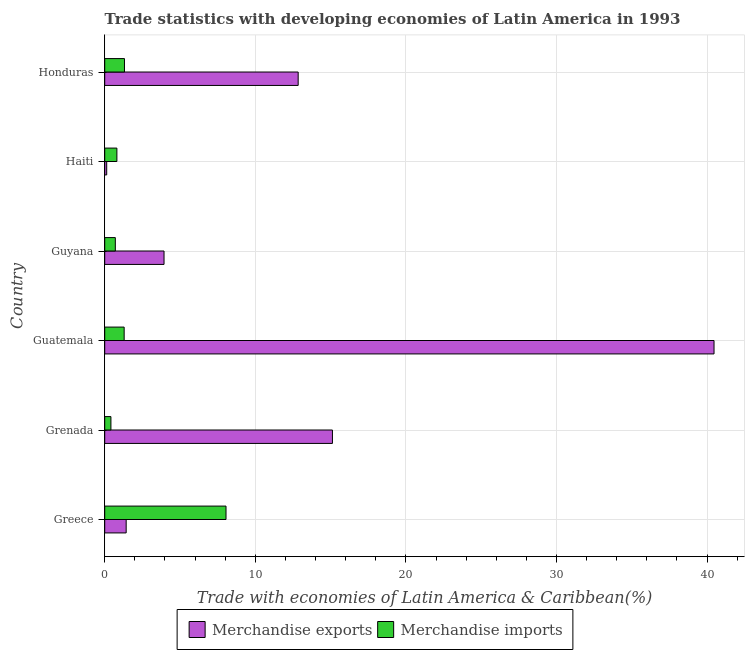How many different coloured bars are there?
Ensure brevity in your answer.  2. How many groups of bars are there?
Provide a short and direct response. 6. Are the number of bars per tick equal to the number of legend labels?
Make the answer very short. Yes. How many bars are there on the 2nd tick from the bottom?
Your response must be concise. 2. What is the label of the 3rd group of bars from the top?
Keep it short and to the point. Guyana. In how many cases, is the number of bars for a given country not equal to the number of legend labels?
Your answer should be compact. 0. What is the merchandise imports in Guatemala?
Your response must be concise. 1.29. Across all countries, what is the maximum merchandise exports?
Keep it short and to the point. 40.46. Across all countries, what is the minimum merchandise imports?
Make the answer very short. 0.41. In which country was the merchandise imports maximum?
Provide a short and direct response. Greece. In which country was the merchandise exports minimum?
Your answer should be compact. Haiti. What is the total merchandise exports in the graph?
Offer a terse response. 73.92. What is the difference between the merchandise imports in Guyana and that in Honduras?
Offer a very short reply. -0.61. What is the difference between the merchandise exports in Honduras and the merchandise imports in Haiti?
Offer a very short reply. 12.04. What is the average merchandise imports per country?
Offer a very short reply. 2.1. What is the difference between the merchandise imports and merchandise exports in Greece?
Your answer should be very brief. 6.63. In how many countries, is the merchandise imports greater than 2 %?
Your answer should be compact. 1. What is the ratio of the merchandise imports in Guyana to that in Honduras?
Keep it short and to the point. 0.54. Is the difference between the merchandise imports in Greece and Guyana greater than the difference between the merchandise exports in Greece and Guyana?
Offer a very short reply. Yes. What is the difference between the highest and the second highest merchandise imports?
Provide a short and direct response. 6.74. What is the difference between the highest and the lowest merchandise exports?
Offer a very short reply. 40.33. In how many countries, is the merchandise imports greater than the average merchandise imports taken over all countries?
Offer a very short reply. 1. Is the sum of the merchandise exports in Grenada and Guyana greater than the maximum merchandise imports across all countries?
Make the answer very short. Yes. What does the 1st bar from the top in Haiti represents?
Your response must be concise. Merchandise imports. How many bars are there?
Your response must be concise. 12. Are all the bars in the graph horizontal?
Offer a very short reply. Yes. How many countries are there in the graph?
Make the answer very short. 6. What is the difference between two consecutive major ticks on the X-axis?
Give a very brief answer. 10. Are the values on the major ticks of X-axis written in scientific E-notation?
Your response must be concise. No. What is the title of the graph?
Provide a short and direct response. Trade statistics with developing economies of Latin America in 1993. Does "Depositors" appear as one of the legend labels in the graph?
Offer a terse response. No. What is the label or title of the X-axis?
Provide a succinct answer. Trade with economies of Latin America & Caribbean(%). What is the Trade with economies of Latin America & Caribbean(%) of Merchandise exports in Greece?
Your answer should be very brief. 1.42. What is the Trade with economies of Latin America & Caribbean(%) of Merchandise imports in Greece?
Ensure brevity in your answer.  8.05. What is the Trade with economies of Latin America & Caribbean(%) in Merchandise exports in Grenada?
Your answer should be compact. 15.12. What is the Trade with economies of Latin America & Caribbean(%) of Merchandise imports in Grenada?
Provide a succinct answer. 0.41. What is the Trade with economies of Latin America & Caribbean(%) of Merchandise exports in Guatemala?
Offer a terse response. 40.46. What is the Trade with economies of Latin America & Caribbean(%) of Merchandise imports in Guatemala?
Offer a very short reply. 1.29. What is the Trade with economies of Latin America & Caribbean(%) in Merchandise exports in Guyana?
Make the answer very short. 3.94. What is the Trade with economies of Latin America & Caribbean(%) of Merchandise imports in Guyana?
Ensure brevity in your answer.  0.7. What is the Trade with economies of Latin America & Caribbean(%) in Merchandise exports in Haiti?
Your answer should be very brief. 0.13. What is the Trade with economies of Latin America & Caribbean(%) in Merchandise imports in Haiti?
Keep it short and to the point. 0.81. What is the Trade with economies of Latin America & Caribbean(%) of Merchandise exports in Honduras?
Your answer should be very brief. 12.85. What is the Trade with economies of Latin America & Caribbean(%) in Merchandise imports in Honduras?
Your response must be concise. 1.31. Across all countries, what is the maximum Trade with economies of Latin America & Caribbean(%) of Merchandise exports?
Make the answer very short. 40.46. Across all countries, what is the maximum Trade with economies of Latin America & Caribbean(%) in Merchandise imports?
Ensure brevity in your answer.  8.05. Across all countries, what is the minimum Trade with economies of Latin America & Caribbean(%) in Merchandise exports?
Ensure brevity in your answer.  0.13. Across all countries, what is the minimum Trade with economies of Latin America & Caribbean(%) of Merchandise imports?
Provide a succinct answer. 0.41. What is the total Trade with economies of Latin America & Caribbean(%) of Merchandise exports in the graph?
Ensure brevity in your answer.  73.92. What is the total Trade with economies of Latin America & Caribbean(%) of Merchandise imports in the graph?
Keep it short and to the point. 12.58. What is the difference between the Trade with economies of Latin America & Caribbean(%) in Merchandise exports in Greece and that in Grenada?
Keep it short and to the point. -13.7. What is the difference between the Trade with economies of Latin America & Caribbean(%) of Merchandise imports in Greece and that in Grenada?
Ensure brevity in your answer.  7.64. What is the difference between the Trade with economies of Latin America & Caribbean(%) in Merchandise exports in Greece and that in Guatemala?
Offer a terse response. -39.04. What is the difference between the Trade with economies of Latin America & Caribbean(%) of Merchandise imports in Greece and that in Guatemala?
Make the answer very short. 6.76. What is the difference between the Trade with economies of Latin America & Caribbean(%) in Merchandise exports in Greece and that in Guyana?
Your response must be concise. -2.51. What is the difference between the Trade with economies of Latin America & Caribbean(%) in Merchandise imports in Greece and that in Guyana?
Provide a short and direct response. 7.35. What is the difference between the Trade with economies of Latin America & Caribbean(%) of Merchandise exports in Greece and that in Haiti?
Offer a terse response. 1.29. What is the difference between the Trade with economies of Latin America & Caribbean(%) of Merchandise imports in Greece and that in Haiti?
Provide a short and direct response. 7.25. What is the difference between the Trade with economies of Latin America & Caribbean(%) of Merchandise exports in Greece and that in Honduras?
Offer a very short reply. -11.42. What is the difference between the Trade with economies of Latin America & Caribbean(%) of Merchandise imports in Greece and that in Honduras?
Provide a succinct answer. 6.74. What is the difference between the Trade with economies of Latin America & Caribbean(%) of Merchandise exports in Grenada and that in Guatemala?
Your answer should be very brief. -25.34. What is the difference between the Trade with economies of Latin America & Caribbean(%) in Merchandise imports in Grenada and that in Guatemala?
Offer a terse response. -0.88. What is the difference between the Trade with economies of Latin America & Caribbean(%) of Merchandise exports in Grenada and that in Guyana?
Provide a short and direct response. 11.18. What is the difference between the Trade with economies of Latin America & Caribbean(%) in Merchandise imports in Grenada and that in Guyana?
Keep it short and to the point. -0.29. What is the difference between the Trade with economies of Latin America & Caribbean(%) of Merchandise exports in Grenada and that in Haiti?
Your response must be concise. 14.99. What is the difference between the Trade with economies of Latin America & Caribbean(%) in Merchandise imports in Grenada and that in Haiti?
Give a very brief answer. -0.4. What is the difference between the Trade with economies of Latin America & Caribbean(%) in Merchandise exports in Grenada and that in Honduras?
Provide a short and direct response. 2.28. What is the difference between the Trade with economies of Latin America & Caribbean(%) of Merchandise imports in Grenada and that in Honduras?
Your answer should be very brief. -0.9. What is the difference between the Trade with economies of Latin America & Caribbean(%) in Merchandise exports in Guatemala and that in Guyana?
Ensure brevity in your answer.  36.52. What is the difference between the Trade with economies of Latin America & Caribbean(%) in Merchandise imports in Guatemala and that in Guyana?
Provide a short and direct response. 0.59. What is the difference between the Trade with economies of Latin America & Caribbean(%) of Merchandise exports in Guatemala and that in Haiti?
Ensure brevity in your answer.  40.33. What is the difference between the Trade with economies of Latin America & Caribbean(%) of Merchandise imports in Guatemala and that in Haiti?
Offer a terse response. 0.48. What is the difference between the Trade with economies of Latin America & Caribbean(%) in Merchandise exports in Guatemala and that in Honduras?
Give a very brief answer. 27.61. What is the difference between the Trade with economies of Latin America & Caribbean(%) in Merchandise imports in Guatemala and that in Honduras?
Your answer should be compact. -0.02. What is the difference between the Trade with economies of Latin America & Caribbean(%) of Merchandise exports in Guyana and that in Haiti?
Give a very brief answer. 3.81. What is the difference between the Trade with economies of Latin America & Caribbean(%) in Merchandise imports in Guyana and that in Haiti?
Keep it short and to the point. -0.1. What is the difference between the Trade with economies of Latin America & Caribbean(%) of Merchandise exports in Guyana and that in Honduras?
Offer a very short reply. -8.91. What is the difference between the Trade with economies of Latin America & Caribbean(%) in Merchandise imports in Guyana and that in Honduras?
Keep it short and to the point. -0.61. What is the difference between the Trade with economies of Latin America & Caribbean(%) of Merchandise exports in Haiti and that in Honduras?
Offer a terse response. -12.71. What is the difference between the Trade with economies of Latin America & Caribbean(%) of Merchandise imports in Haiti and that in Honduras?
Your answer should be compact. -0.5. What is the difference between the Trade with economies of Latin America & Caribbean(%) of Merchandise exports in Greece and the Trade with economies of Latin America & Caribbean(%) of Merchandise imports in Grenada?
Your answer should be very brief. 1.01. What is the difference between the Trade with economies of Latin America & Caribbean(%) in Merchandise exports in Greece and the Trade with economies of Latin America & Caribbean(%) in Merchandise imports in Guatemala?
Offer a terse response. 0.13. What is the difference between the Trade with economies of Latin America & Caribbean(%) in Merchandise exports in Greece and the Trade with economies of Latin America & Caribbean(%) in Merchandise imports in Guyana?
Offer a very short reply. 0.72. What is the difference between the Trade with economies of Latin America & Caribbean(%) in Merchandise exports in Greece and the Trade with economies of Latin America & Caribbean(%) in Merchandise imports in Haiti?
Provide a succinct answer. 0.62. What is the difference between the Trade with economies of Latin America & Caribbean(%) in Merchandise exports in Greece and the Trade with economies of Latin America & Caribbean(%) in Merchandise imports in Honduras?
Provide a succinct answer. 0.11. What is the difference between the Trade with economies of Latin America & Caribbean(%) of Merchandise exports in Grenada and the Trade with economies of Latin America & Caribbean(%) of Merchandise imports in Guatemala?
Ensure brevity in your answer.  13.83. What is the difference between the Trade with economies of Latin America & Caribbean(%) in Merchandise exports in Grenada and the Trade with economies of Latin America & Caribbean(%) in Merchandise imports in Guyana?
Ensure brevity in your answer.  14.42. What is the difference between the Trade with economies of Latin America & Caribbean(%) in Merchandise exports in Grenada and the Trade with economies of Latin America & Caribbean(%) in Merchandise imports in Haiti?
Your response must be concise. 14.31. What is the difference between the Trade with economies of Latin America & Caribbean(%) of Merchandise exports in Grenada and the Trade with economies of Latin America & Caribbean(%) of Merchandise imports in Honduras?
Your answer should be compact. 13.81. What is the difference between the Trade with economies of Latin America & Caribbean(%) in Merchandise exports in Guatemala and the Trade with economies of Latin America & Caribbean(%) in Merchandise imports in Guyana?
Keep it short and to the point. 39.76. What is the difference between the Trade with economies of Latin America & Caribbean(%) in Merchandise exports in Guatemala and the Trade with economies of Latin America & Caribbean(%) in Merchandise imports in Haiti?
Your response must be concise. 39.65. What is the difference between the Trade with economies of Latin America & Caribbean(%) in Merchandise exports in Guatemala and the Trade with economies of Latin America & Caribbean(%) in Merchandise imports in Honduras?
Provide a short and direct response. 39.15. What is the difference between the Trade with economies of Latin America & Caribbean(%) in Merchandise exports in Guyana and the Trade with economies of Latin America & Caribbean(%) in Merchandise imports in Haiti?
Make the answer very short. 3.13. What is the difference between the Trade with economies of Latin America & Caribbean(%) in Merchandise exports in Guyana and the Trade with economies of Latin America & Caribbean(%) in Merchandise imports in Honduras?
Provide a short and direct response. 2.63. What is the difference between the Trade with economies of Latin America & Caribbean(%) in Merchandise exports in Haiti and the Trade with economies of Latin America & Caribbean(%) in Merchandise imports in Honduras?
Provide a succinct answer. -1.18. What is the average Trade with economies of Latin America & Caribbean(%) in Merchandise exports per country?
Give a very brief answer. 12.32. What is the average Trade with economies of Latin America & Caribbean(%) of Merchandise imports per country?
Provide a short and direct response. 2.1. What is the difference between the Trade with economies of Latin America & Caribbean(%) in Merchandise exports and Trade with economies of Latin America & Caribbean(%) in Merchandise imports in Greece?
Offer a very short reply. -6.63. What is the difference between the Trade with economies of Latin America & Caribbean(%) of Merchandise exports and Trade with economies of Latin America & Caribbean(%) of Merchandise imports in Grenada?
Your answer should be compact. 14.71. What is the difference between the Trade with economies of Latin America & Caribbean(%) of Merchandise exports and Trade with economies of Latin America & Caribbean(%) of Merchandise imports in Guatemala?
Your answer should be compact. 39.17. What is the difference between the Trade with economies of Latin America & Caribbean(%) of Merchandise exports and Trade with economies of Latin America & Caribbean(%) of Merchandise imports in Guyana?
Give a very brief answer. 3.23. What is the difference between the Trade with economies of Latin America & Caribbean(%) of Merchandise exports and Trade with economies of Latin America & Caribbean(%) of Merchandise imports in Haiti?
Your response must be concise. -0.68. What is the difference between the Trade with economies of Latin America & Caribbean(%) in Merchandise exports and Trade with economies of Latin America & Caribbean(%) in Merchandise imports in Honduras?
Ensure brevity in your answer.  11.54. What is the ratio of the Trade with economies of Latin America & Caribbean(%) of Merchandise exports in Greece to that in Grenada?
Offer a terse response. 0.09. What is the ratio of the Trade with economies of Latin America & Caribbean(%) in Merchandise imports in Greece to that in Grenada?
Offer a terse response. 19.56. What is the ratio of the Trade with economies of Latin America & Caribbean(%) in Merchandise exports in Greece to that in Guatemala?
Offer a very short reply. 0.04. What is the ratio of the Trade with economies of Latin America & Caribbean(%) in Merchandise imports in Greece to that in Guatemala?
Provide a short and direct response. 6.24. What is the ratio of the Trade with economies of Latin America & Caribbean(%) in Merchandise exports in Greece to that in Guyana?
Your response must be concise. 0.36. What is the ratio of the Trade with economies of Latin America & Caribbean(%) of Merchandise imports in Greece to that in Guyana?
Give a very brief answer. 11.44. What is the ratio of the Trade with economies of Latin America & Caribbean(%) in Merchandise exports in Greece to that in Haiti?
Provide a succinct answer. 10.78. What is the ratio of the Trade with economies of Latin America & Caribbean(%) in Merchandise imports in Greece to that in Haiti?
Make the answer very short. 9.97. What is the ratio of the Trade with economies of Latin America & Caribbean(%) in Merchandise exports in Greece to that in Honduras?
Offer a very short reply. 0.11. What is the ratio of the Trade with economies of Latin America & Caribbean(%) of Merchandise imports in Greece to that in Honduras?
Make the answer very short. 6.14. What is the ratio of the Trade with economies of Latin America & Caribbean(%) of Merchandise exports in Grenada to that in Guatemala?
Offer a terse response. 0.37. What is the ratio of the Trade with economies of Latin America & Caribbean(%) in Merchandise imports in Grenada to that in Guatemala?
Your answer should be very brief. 0.32. What is the ratio of the Trade with economies of Latin America & Caribbean(%) in Merchandise exports in Grenada to that in Guyana?
Keep it short and to the point. 3.84. What is the ratio of the Trade with economies of Latin America & Caribbean(%) of Merchandise imports in Grenada to that in Guyana?
Provide a short and direct response. 0.58. What is the ratio of the Trade with economies of Latin America & Caribbean(%) of Merchandise exports in Grenada to that in Haiti?
Keep it short and to the point. 114.48. What is the ratio of the Trade with economies of Latin America & Caribbean(%) in Merchandise imports in Grenada to that in Haiti?
Provide a short and direct response. 0.51. What is the ratio of the Trade with economies of Latin America & Caribbean(%) of Merchandise exports in Grenada to that in Honduras?
Your answer should be very brief. 1.18. What is the ratio of the Trade with economies of Latin America & Caribbean(%) of Merchandise imports in Grenada to that in Honduras?
Ensure brevity in your answer.  0.31. What is the ratio of the Trade with economies of Latin America & Caribbean(%) of Merchandise exports in Guatemala to that in Guyana?
Provide a short and direct response. 10.27. What is the ratio of the Trade with economies of Latin America & Caribbean(%) in Merchandise imports in Guatemala to that in Guyana?
Ensure brevity in your answer.  1.83. What is the ratio of the Trade with economies of Latin America & Caribbean(%) in Merchandise exports in Guatemala to that in Haiti?
Keep it short and to the point. 306.3. What is the ratio of the Trade with economies of Latin America & Caribbean(%) in Merchandise imports in Guatemala to that in Haiti?
Your response must be concise. 1.6. What is the ratio of the Trade with economies of Latin America & Caribbean(%) in Merchandise exports in Guatemala to that in Honduras?
Your answer should be compact. 3.15. What is the ratio of the Trade with economies of Latin America & Caribbean(%) in Merchandise imports in Guatemala to that in Honduras?
Provide a succinct answer. 0.98. What is the ratio of the Trade with economies of Latin America & Caribbean(%) of Merchandise exports in Guyana to that in Haiti?
Your answer should be compact. 29.82. What is the ratio of the Trade with economies of Latin America & Caribbean(%) of Merchandise imports in Guyana to that in Haiti?
Offer a very short reply. 0.87. What is the ratio of the Trade with economies of Latin America & Caribbean(%) of Merchandise exports in Guyana to that in Honduras?
Offer a terse response. 0.31. What is the ratio of the Trade with economies of Latin America & Caribbean(%) in Merchandise imports in Guyana to that in Honduras?
Offer a terse response. 0.54. What is the ratio of the Trade with economies of Latin America & Caribbean(%) in Merchandise exports in Haiti to that in Honduras?
Offer a terse response. 0.01. What is the ratio of the Trade with economies of Latin America & Caribbean(%) of Merchandise imports in Haiti to that in Honduras?
Ensure brevity in your answer.  0.62. What is the difference between the highest and the second highest Trade with economies of Latin America & Caribbean(%) of Merchandise exports?
Your answer should be very brief. 25.34. What is the difference between the highest and the second highest Trade with economies of Latin America & Caribbean(%) of Merchandise imports?
Your answer should be compact. 6.74. What is the difference between the highest and the lowest Trade with economies of Latin America & Caribbean(%) in Merchandise exports?
Offer a very short reply. 40.33. What is the difference between the highest and the lowest Trade with economies of Latin America & Caribbean(%) in Merchandise imports?
Ensure brevity in your answer.  7.64. 